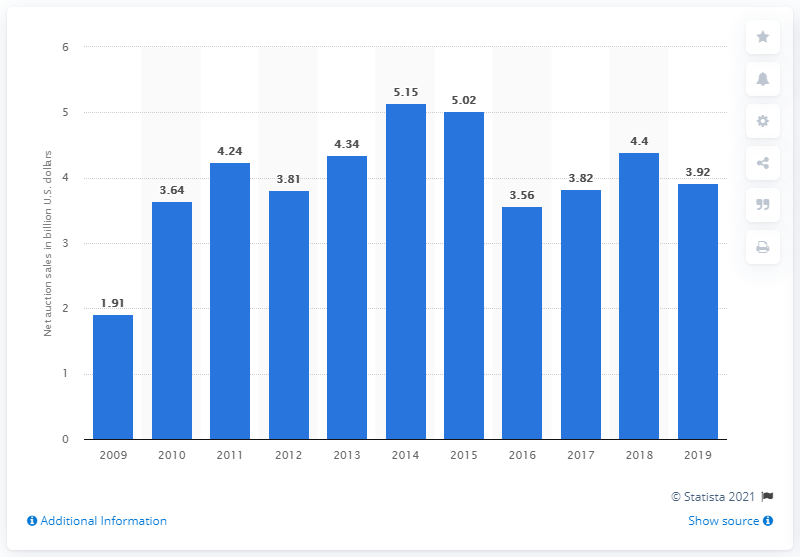Outline some significant characteristics in this image. In the previous year, Sotheby's net auction sales were 4.4 billion. In 2019, Sotheby's net auction sales were 3.92 billion dollars. 